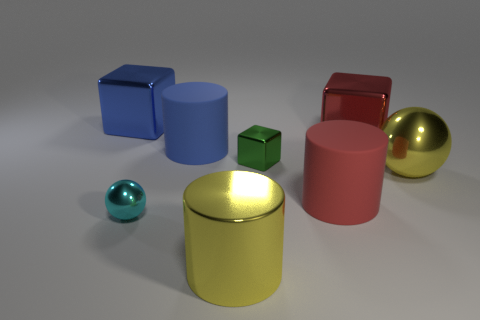Add 1 yellow matte cylinders. How many objects exist? 9 Subtract all large blue blocks. How many blocks are left? 2 Subtract all red cylinders. How many cylinders are left? 2 Subtract 1 blue cylinders. How many objects are left? 7 Subtract all cylinders. How many objects are left? 5 Subtract 2 balls. How many balls are left? 0 Subtract all blue balls. Subtract all cyan cylinders. How many balls are left? 2 Subtract all blue cylinders. How many yellow cubes are left? 0 Subtract all cubes. Subtract all yellow objects. How many objects are left? 3 Add 5 yellow objects. How many yellow objects are left? 7 